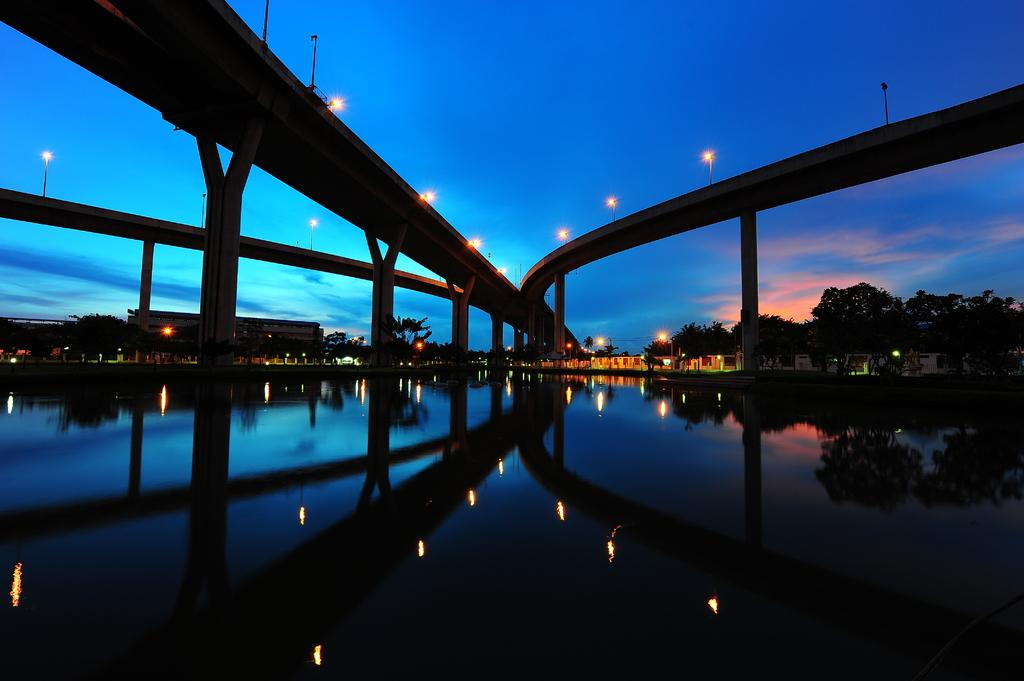What is illuminated on the bridge in the image? There are lights on a bridge in the image. What is the natural element flowing in the image? There is water flowing in the image. What type of structures can be seen in the background of the image? There are buildings visible in the background of the image. What type of vegetation is present in the background of the image? There are trees present in the background of the image. What color is the bear's shirt in the image? There is no bear or shirt present in the image. What does the bear feel in the image? There is no bear present in the image, so it cannot feel any emotions such as shame. 